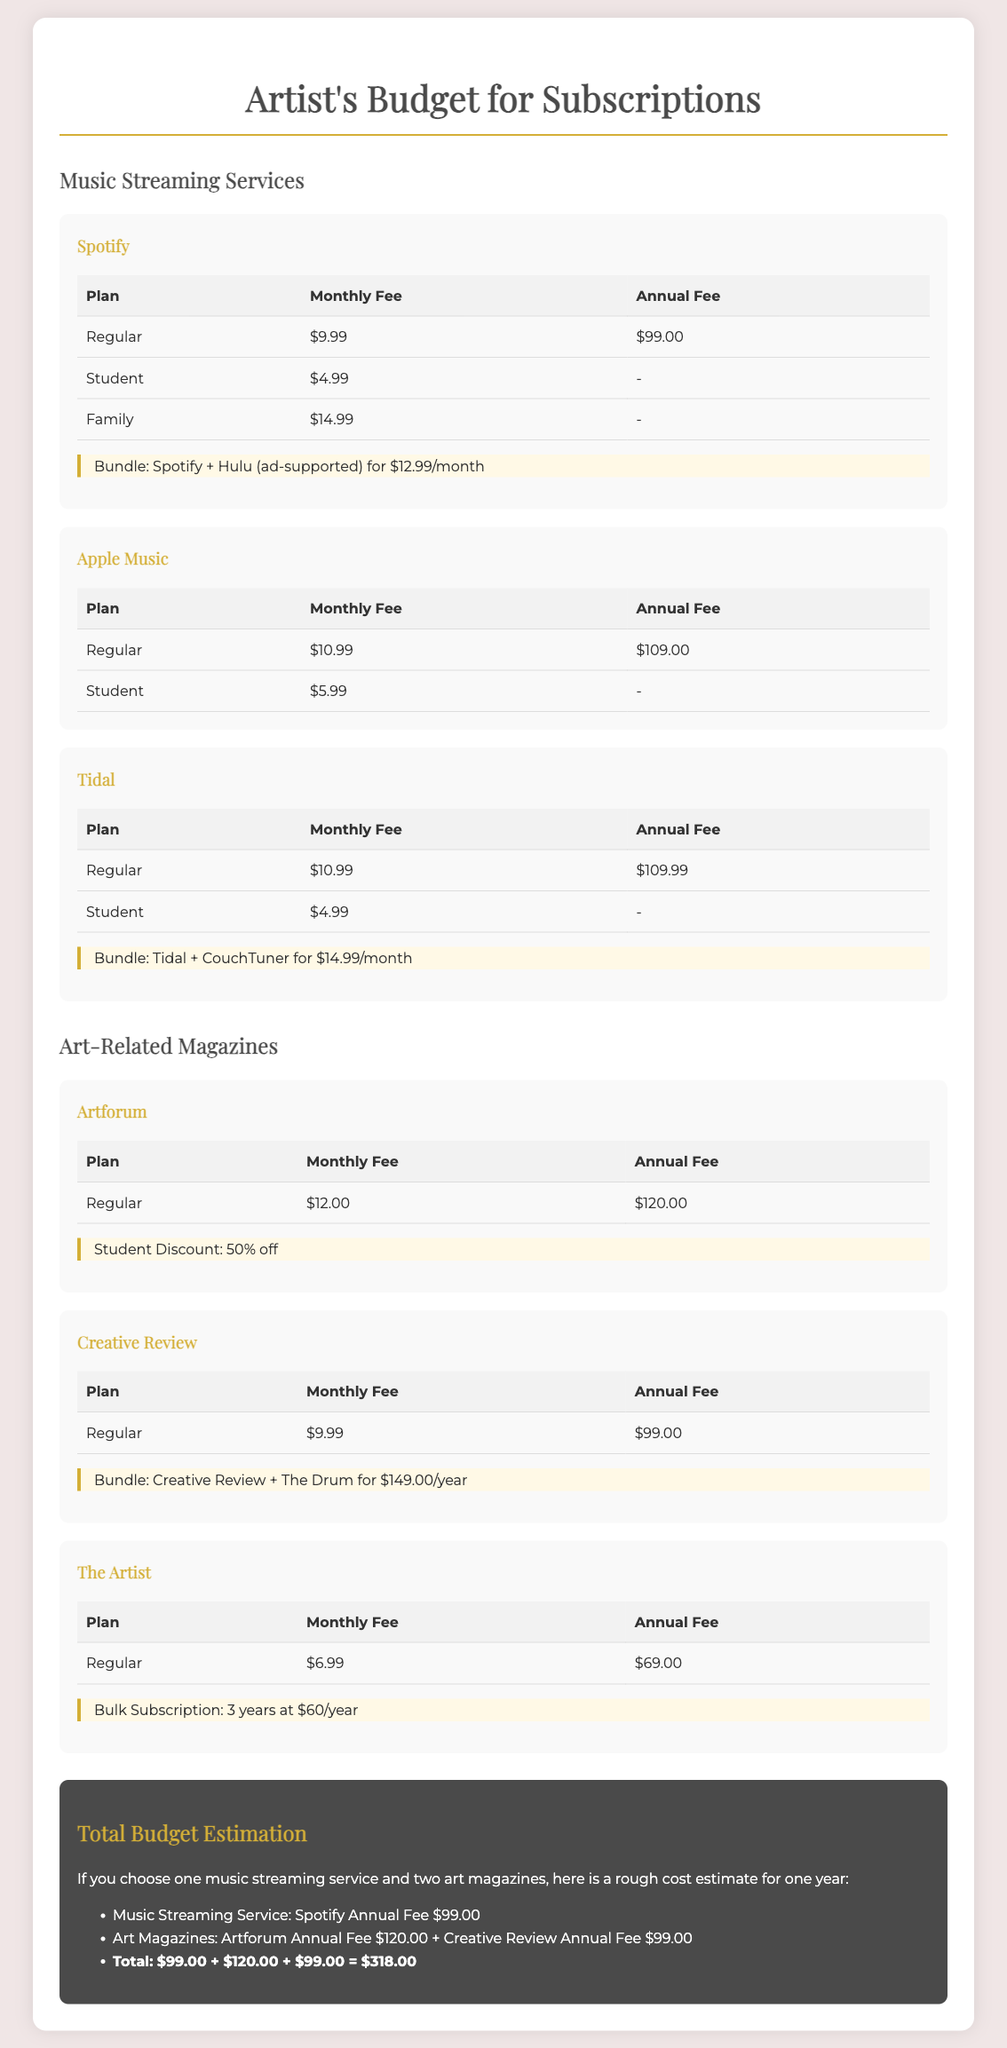What is the monthly fee for Spotify's Regular plan? The monthly fee for the Regular plan on Spotify is listed in the table as $9.99.
Answer: $9.99 What is the student discount for Artforum? The document states that Artforum offers a student discount of 50% off, which is highlighted in the relevant section.
Answer: 50% off What is the total estimated budget if one music streaming service and two art magazines are chosen? The total budget estimation provided in the document sums up to $318.00 when calculated from the fees of the selected services and magazines.
Answer: $318.00 What is the combined monthly fee for Tidal's Regular plan and The Artist? The monthly fee combined for Tidal's Regular plan ($10.99) and The Artist ($6.99) totals $17.98, which requires addition of the two fees.
Answer: $17.98 What is the annual fee for Apple Music's Regular plan? The annual fee for Apple Music's Regular plan is listed in the document as $109.00.
Answer: $109.00 What bundled package does Spotify offer? The document highlights that Spotify offers a bundle with Hulu (ad-supported) for $12.99/month.
Answer: $12.99/month How much is the fee for Creative Review's Regular plan? The fee for Creative Review's Regular plan is listed as $9.99 monthly in the document.
Answer: $9.99 What is the annual fee for bulk subscription to The Artist for three years? The document states that the bulk subscription for The Artist is $60/year for three years, culminating in a total of $180.
Answer: $60/year Which service offers a bundled package with CouchTuner? Tidal is identified in the document as offering a bundled package with CouchTuner for $14.99/month.
Answer: Tidal 